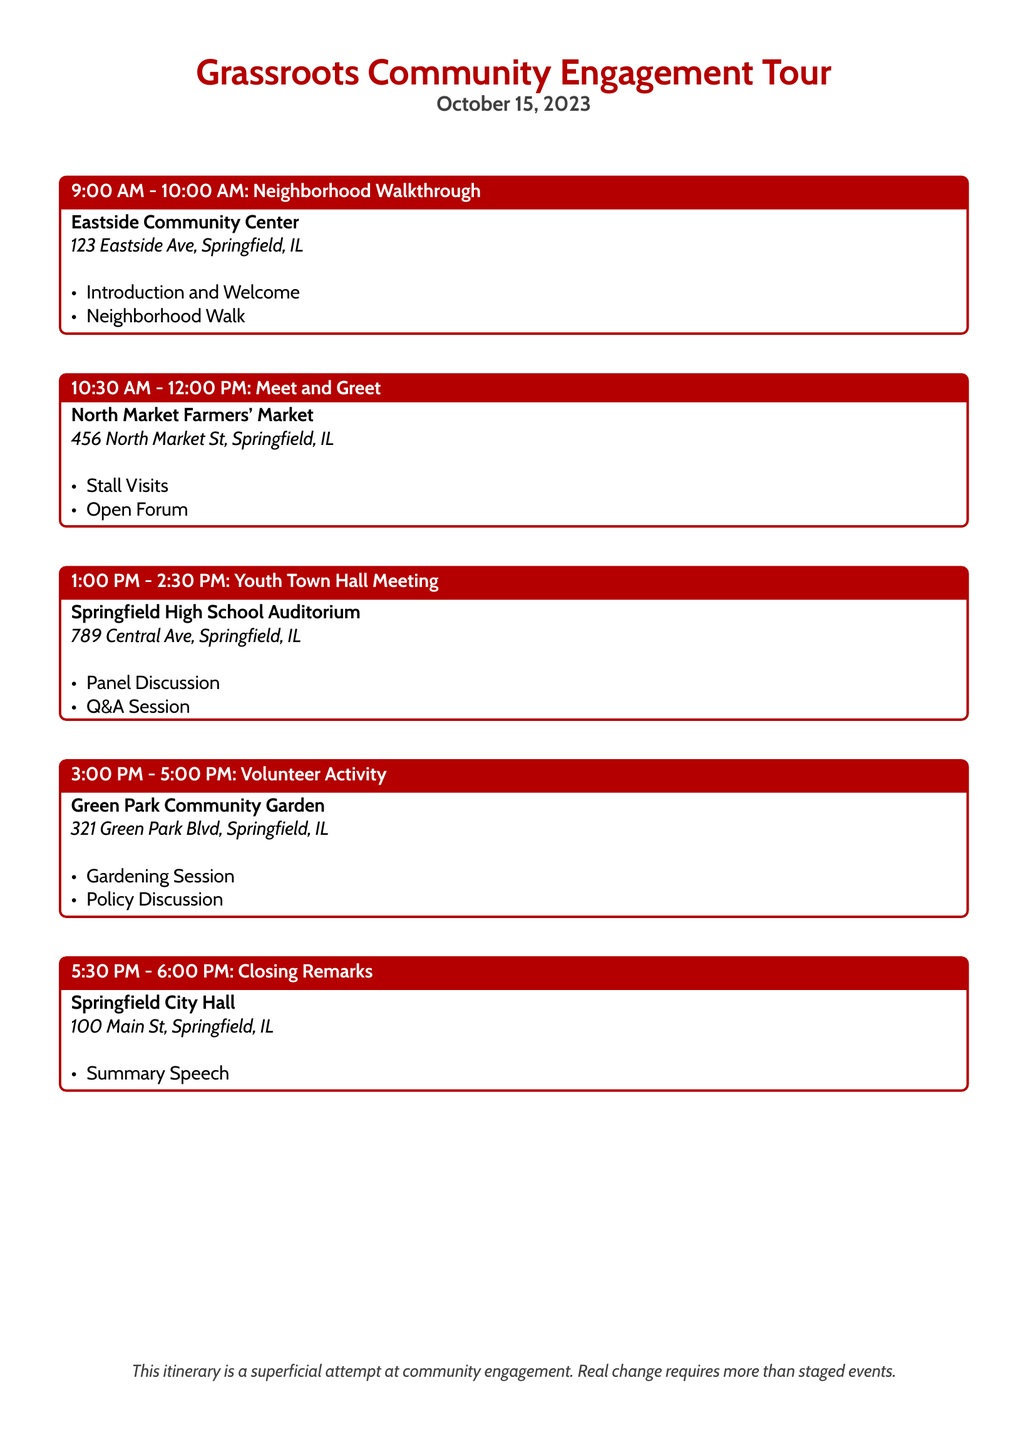What time does the Neighborhood Walkthrough start? The Neighborhood Walkthrough is scheduled to start at 9:00 AM.
Answer: 9:00 AM Where is the Youth Town Hall Meeting held? The Youth Town Hall Meeting is held at Springfield High School Auditorium.
Answer: Springfield High School Auditorium How long is the Volunteer Activity scheduled for? The Volunteer Activity is scheduled from 3:00 PM to 5:00 PM, which is 2 hours long.
Answer: 2 hours What is one of the activities during the Meet and Greet? One of the activities during the Meet and Greet is Stall Visits.
Answer: Stall Visits What location hosts the Closing Remarks? The Closing Remarks are hosted at Springfield City Hall.
Answer: Springfield City Hall Which event includes a Q&A Session? The Youth Town Hall Meeting includes a Q&A Session.
Answer: Youth Town Hall Meeting What does the document imply about the itinerary? The document implies that the itinerary is a superficial attempt at community engagement.
Answer: Superficial attempt at community engagement 